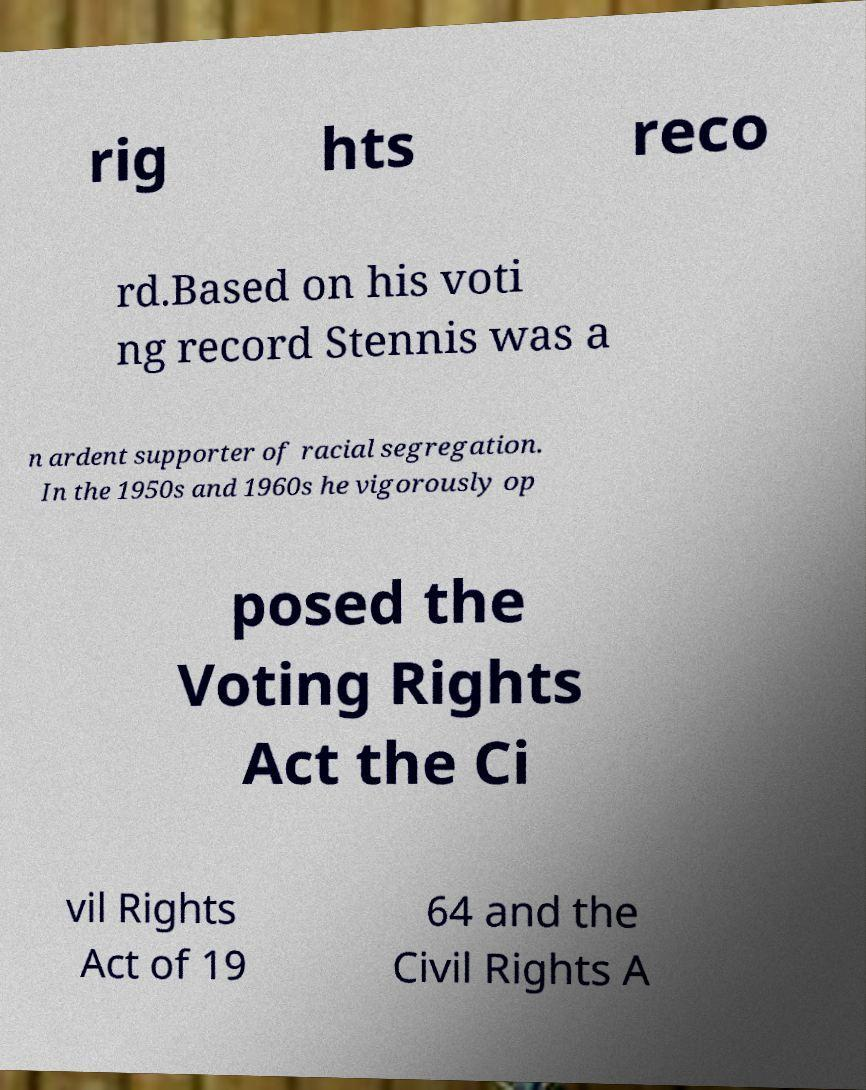Can you accurately transcribe the text from the provided image for me? rig hts reco rd.Based on his voti ng record Stennis was a n ardent supporter of racial segregation. In the 1950s and 1960s he vigorously op posed the Voting Rights Act the Ci vil Rights Act of 19 64 and the Civil Rights A 